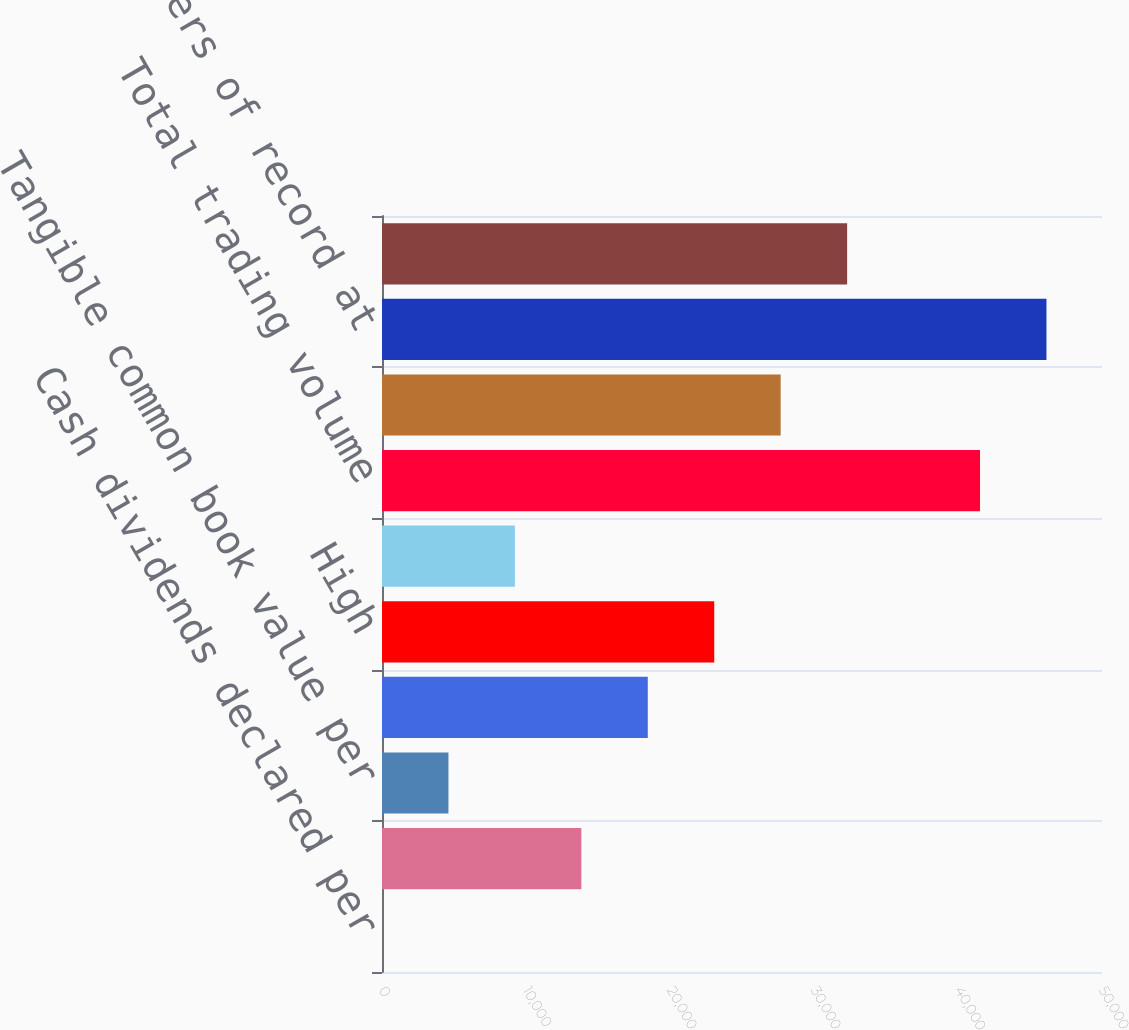<chart> <loc_0><loc_0><loc_500><loc_500><bar_chart><fcel>Cash dividends declared per<fcel>Common equity book value per<fcel>Tangible common book value per<fcel>Market value at year-end<fcel>High<fcel>Low<fcel>Total trading volume<fcel>Dividend payout ratio<fcel>Stockholders of record at<fcel>Basic<nl><fcel>0.32<fcel>13843.1<fcel>4614.59<fcel>18457.4<fcel>23071.7<fcel>9228.86<fcel>41528.8<fcel>27685.9<fcel>46143<fcel>32300.2<nl></chart> 